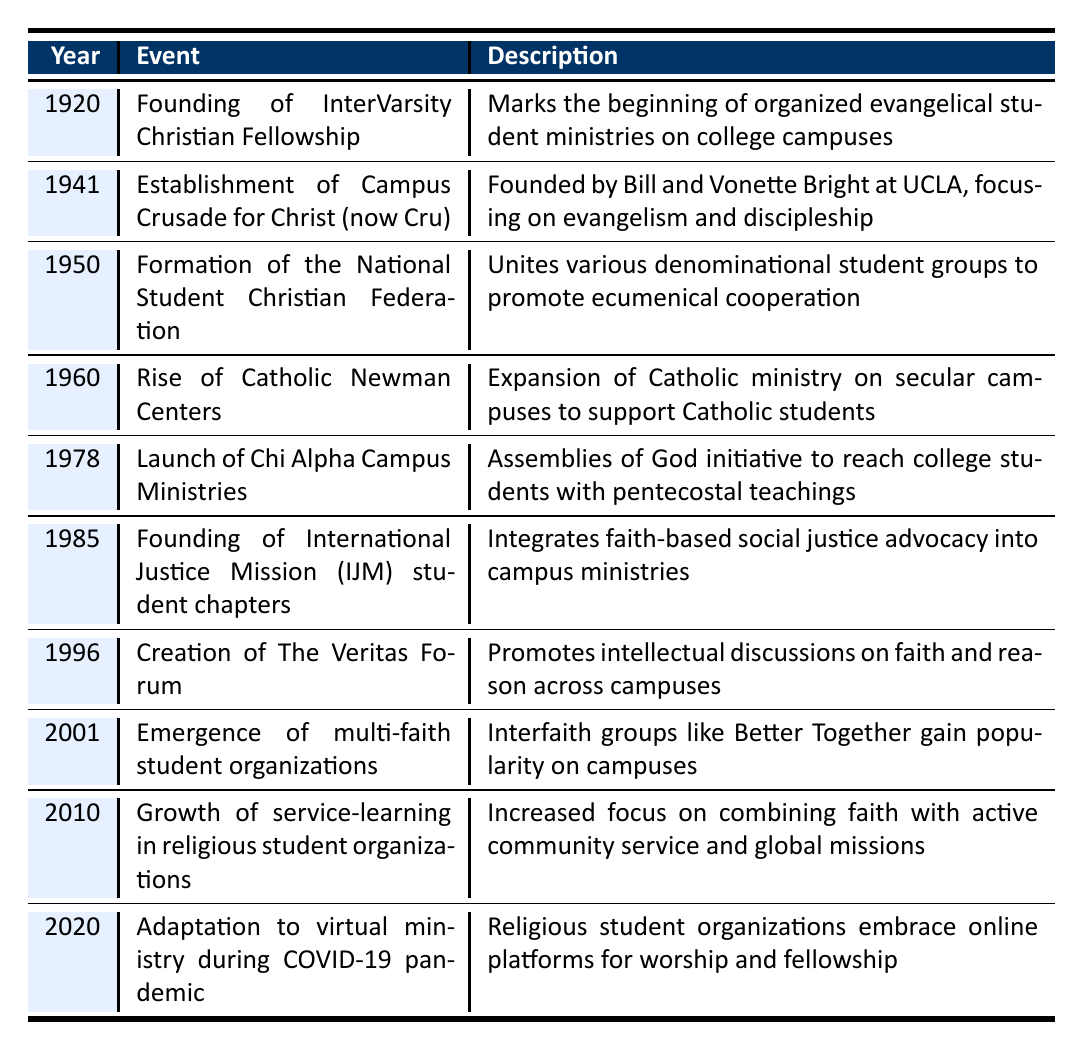What year was the InterVarsity Christian Fellowship founded? The table lists the founding of InterVarsity Christian Fellowship in the year 1920. Therefore, referring to the first row of the table directly answers the question.
Answer: 1920 Which event marked the beginning of organized evangelical student ministries on college campuses? According to the description in the table, the founding of InterVarsity Christian Fellowship in 1920 is identified as the event that marks the beginning of organized evangelical student ministries.
Answer: Founding of InterVarsity Christian Fellowship How many years apart was the formation of the National Student Christian Federation from the establishment of Campus Crusade for Christ? The National Student Christian Federation was formed in 1950, and Campus Crusade for Christ was established in 1941. The difference between these two years is 1950 - 1941 = 9 years.
Answer: 9 years Did the launch of Chi Alpha Campus Ministries occur before or after the emergence of multi-faith student organizations? The launch of Chi Alpha Campus Ministries took place in 1978, while the emergence of multi-faith student organizations is noted in 2001. Since 1978 is before 2001, the statement is true.
Answer: Yes What was the primary focus of religious student organizations in 2010? The table states that in 2010, the growth of service-learning in religious student organizations focused on combining faith with active community service and global missions. Consulting the corresponding row in the table provides this information.
Answer: Combining faith with active community service What events occurred between the years 1960 and 1985? From the table, the events occurring in that timeframe are the rise of Catholic Newman Centers in 1960, the launch of Chi Alpha Campus Ministries in 1978, and the founding of International Justice Mission student chapters in 1985. By reviewing the years in the table, we can compile these events effectively.
Answer: Rise of Catholic Newman Centers, Launch of Chi Alpha Campus Ministries, Founding of IJM student chapters What trend can be observed from the events listed from 2001 to 2020? The trend from 2001 to 2020 shows a shift towards inclusion and adaptability in religious student organizations, as indicated by the emergence of multi-faith organizations in 2001, growth of service-learning in 2010, and adaptation to virtual ministry in 2020. Analyzing the events in this range reveals that religious organizations became more inclusive and technologically integrated.
Answer: Shift towards inclusion and adaptability Is the description for the event in 1996 related to faith, reason, or service? The description for the event in 1996, which is the creation of The Veritas Forum, states it promotes intellectual discussions on faith and reason. Therefore, the focus of this event is related more to faith and reason rather than service.
Answer: Faith and reason In what decade did the emergence of multi-faith student organizations occur? The emergence of multi-faith student organizations was noted in the year 2001. Since this year falls within the 2000s, the decade in which this happened is the 2000s. Referring to the year provided answers the question of which decade it was.
Answer: 2000s 